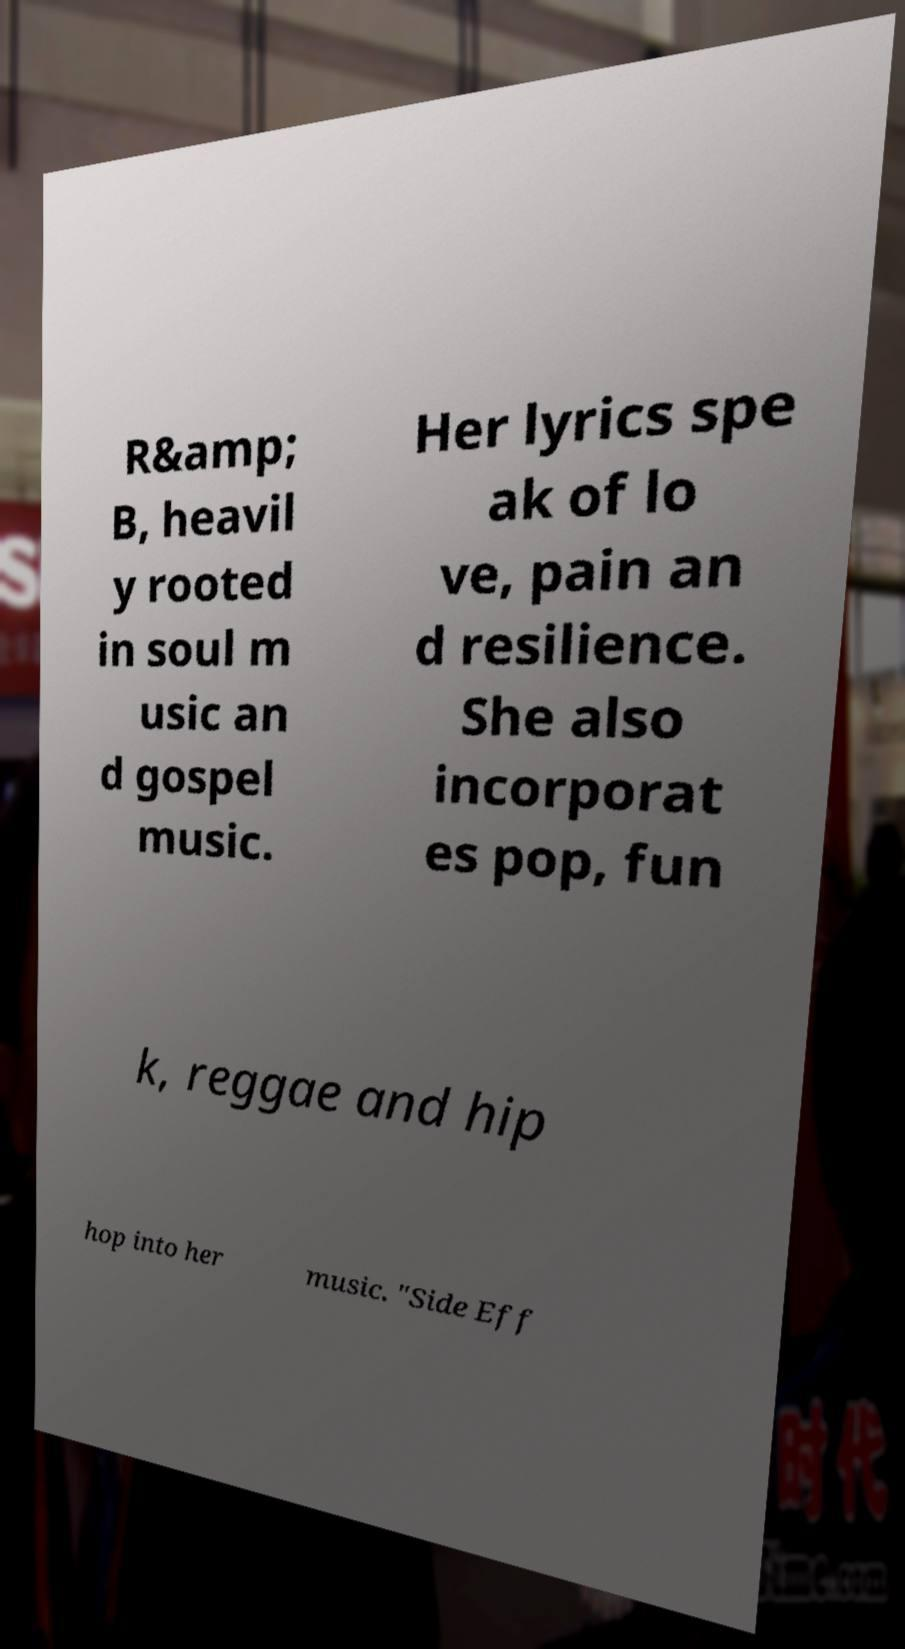Could you assist in decoding the text presented in this image and type it out clearly? R&amp; B, heavil y rooted in soul m usic an d gospel music. Her lyrics spe ak of lo ve, pain an d resilience. She also incorporat es pop, fun k, reggae and hip hop into her music. "Side Eff 